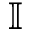Convert formula to latex. <formula><loc_0><loc_0><loc_500><loc_500>\mathbb { I }</formula> 